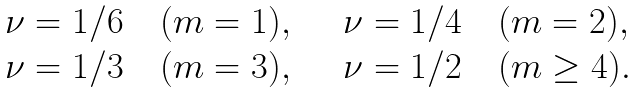<formula> <loc_0><loc_0><loc_500><loc_500>\begin{array} { l l } \nu = 1 / 6 \quad ( m = 1 ) , \quad & \nu = 1 / 4 \quad ( m = 2 ) , \\ \nu = 1 / 3 \quad ( m = 3 ) , \quad & \nu = 1 / 2 \quad ( m \geq 4 ) . \end{array}</formula> 